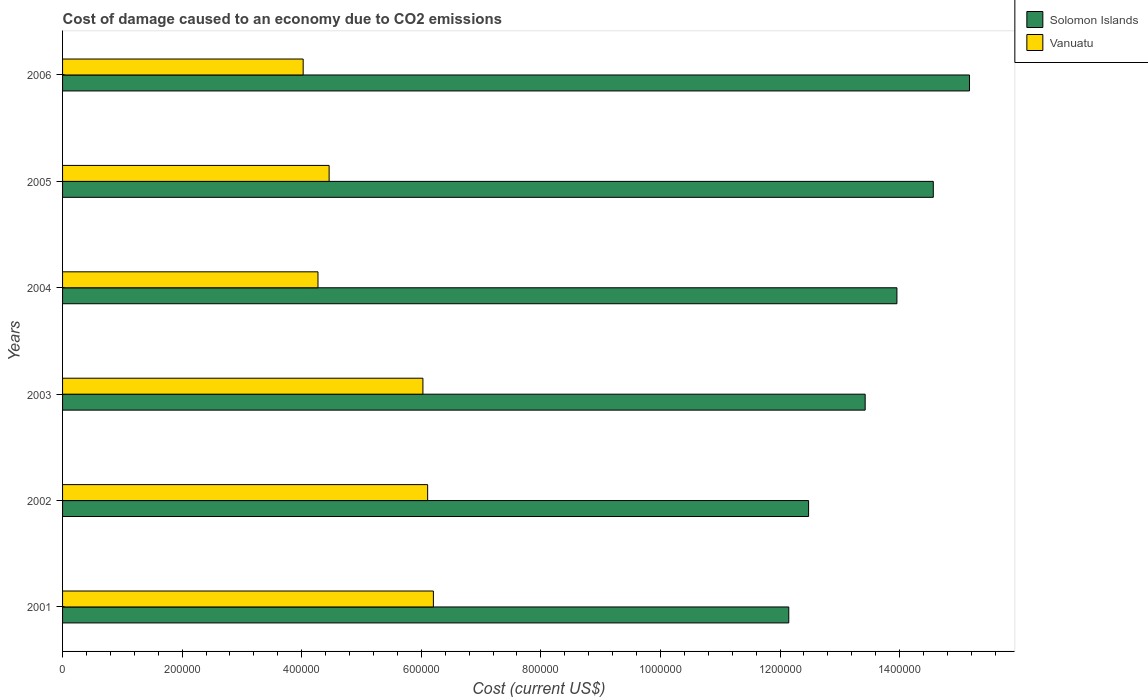How many groups of bars are there?
Provide a succinct answer. 6. Are the number of bars on each tick of the Y-axis equal?
Give a very brief answer. Yes. What is the label of the 1st group of bars from the top?
Offer a terse response. 2006. In how many cases, is the number of bars for a given year not equal to the number of legend labels?
Make the answer very short. 0. What is the cost of damage caused due to CO2 emissisons in Vanuatu in 2002?
Your answer should be compact. 6.11e+05. Across all years, what is the maximum cost of damage caused due to CO2 emissisons in Solomon Islands?
Provide a short and direct response. 1.52e+06. Across all years, what is the minimum cost of damage caused due to CO2 emissisons in Solomon Islands?
Keep it short and to the point. 1.21e+06. In which year was the cost of damage caused due to CO2 emissisons in Solomon Islands minimum?
Offer a very short reply. 2001. What is the total cost of damage caused due to CO2 emissisons in Solomon Islands in the graph?
Make the answer very short. 8.17e+06. What is the difference between the cost of damage caused due to CO2 emissisons in Vanuatu in 2001 and that in 2005?
Offer a very short reply. 1.74e+05. What is the difference between the cost of damage caused due to CO2 emissisons in Solomon Islands in 2004 and the cost of damage caused due to CO2 emissisons in Vanuatu in 2003?
Ensure brevity in your answer.  7.93e+05. What is the average cost of damage caused due to CO2 emissisons in Vanuatu per year?
Ensure brevity in your answer.  5.18e+05. In the year 2005, what is the difference between the cost of damage caused due to CO2 emissisons in Vanuatu and cost of damage caused due to CO2 emissisons in Solomon Islands?
Offer a terse response. -1.01e+06. In how many years, is the cost of damage caused due to CO2 emissisons in Solomon Islands greater than 360000 US$?
Keep it short and to the point. 6. What is the ratio of the cost of damage caused due to CO2 emissisons in Vanuatu in 2004 to that in 2006?
Keep it short and to the point. 1.06. What is the difference between the highest and the second highest cost of damage caused due to CO2 emissisons in Vanuatu?
Your answer should be compact. 9623.03. What is the difference between the highest and the lowest cost of damage caused due to CO2 emissisons in Solomon Islands?
Your response must be concise. 3.02e+05. In how many years, is the cost of damage caused due to CO2 emissisons in Vanuatu greater than the average cost of damage caused due to CO2 emissisons in Vanuatu taken over all years?
Your response must be concise. 3. What does the 2nd bar from the top in 2004 represents?
Offer a very short reply. Solomon Islands. What does the 2nd bar from the bottom in 2006 represents?
Provide a short and direct response. Vanuatu. How many bars are there?
Offer a very short reply. 12. Are all the bars in the graph horizontal?
Provide a short and direct response. Yes. How many years are there in the graph?
Provide a short and direct response. 6. What is the difference between two consecutive major ticks on the X-axis?
Your response must be concise. 2.00e+05. Does the graph contain any zero values?
Provide a succinct answer. No. Where does the legend appear in the graph?
Offer a very short reply. Top right. How many legend labels are there?
Keep it short and to the point. 2. How are the legend labels stacked?
Provide a short and direct response. Vertical. What is the title of the graph?
Offer a very short reply. Cost of damage caused to an economy due to CO2 emissions. Does "Germany" appear as one of the legend labels in the graph?
Provide a succinct answer. No. What is the label or title of the X-axis?
Provide a succinct answer. Cost (current US$). What is the label or title of the Y-axis?
Keep it short and to the point. Years. What is the Cost (current US$) of Solomon Islands in 2001?
Make the answer very short. 1.21e+06. What is the Cost (current US$) of Vanuatu in 2001?
Make the answer very short. 6.20e+05. What is the Cost (current US$) in Solomon Islands in 2002?
Keep it short and to the point. 1.25e+06. What is the Cost (current US$) in Vanuatu in 2002?
Offer a very short reply. 6.11e+05. What is the Cost (current US$) of Solomon Islands in 2003?
Provide a succinct answer. 1.34e+06. What is the Cost (current US$) in Vanuatu in 2003?
Your answer should be very brief. 6.03e+05. What is the Cost (current US$) of Solomon Islands in 2004?
Provide a short and direct response. 1.40e+06. What is the Cost (current US$) in Vanuatu in 2004?
Make the answer very short. 4.27e+05. What is the Cost (current US$) of Solomon Islands in 2005?
Give a very brief answer. 1.46e+06. What is the Cost (current US$) of Vanuatu in 2005?
Offer a terse response. 4.46e+05. What is the Cost (current US$) of Solomon Islands in 2006?
Ensure brevity in your answer.  1.52e+06. What is the Cost (current US$) in Vanuatu in 2006?
Offer a terse response. 4.02e+05. Across all years, what is the maximum Cost (current US$) of Solomon Islands?
Provide a short and direct response. 1.52e+06. Across all years, what is the maximum Cost (current US$) in Vanuatu?
Ensure brevity in your answer.  6.20e+05. Across all years, what is the minimum Cost (current US$) of Solomon Islands?
Your answer should be compact. 1.21e+06. Across all years, what is the minimum Cost (current US$) of Vanuatu?
Your answer should be very brief. 4.02e+05. What is the total Cost (current US$) of Solomon Islands in the graph?
Offer a very short reply. 8.17e+06. What is the total Cost (current US$) in Vanuatu in the graph?
Provide a short and direct response. 3.11e+06. What is the difference between the Cost (current US$) of Solomon Islands in 2001 and that in 2002?
Give a very brief answer. -3.31e+04. What is the difference between the Cost (current US$) in Vanuatu in 2001 and that in 2002?
Give a very brief answer. 9623.03. What is the difference between the Cost (current US$) in Solomon Islands in 2001 and that in 2003?
Your answer should be compact. -1.28e+05. What is the difference between the Cost (current US$) in Vanuatu in 2001 and that in 2003?
Make the answer very short. 1.75e+04. What is the difference between the Cost (current US$) of Solomon Islands in 2001 and that in 2004?
Give a very brief answer. -1.81e+05. What is the difference between the Cost (current US$) in Vanuatu in 2001 and that in 2004?
Provide a short and direct response. 1.93e+05. What is the difference between the Cost (current US$) in Solomon Islands in 2001 and that in 2005?
Keep it short and to the point. -2.42e+05. What is the difference between the Cost (current US$) in Vanuatu in 2001 and that in 2005?
Provide a short and direct response. 1.74e+05. What is the difference between the Cost (current US$) in Solomon Islands in 2001 and that in 2006?
Your response must be concise. -3.02e+05. What is the difference between the Cost (current US$) of Vanuatu in 2001 and that in 2006?
Make the answer very short. 2.18e+05. What is the difference between the Cost (current US$) of Solomon Islands in 2002 and that in 2003?
Give a very brief answer. -9.46e+04. What is the difference between the Cost (current US$) of Vanuatu in 2002 and that in 2003?
Keep it short and to the point. 7900.54. What is the difference between the Cost (current US$) in Solomon Islands in 2002 and that in 2004?
Offer a terse response. -1.48e+05. What is the difference between the Cost (current US$) in Vanuatu in 2002 and that in 2004?
Keep it short and to the point. 1.83e+05. What is the difference between the Cost (current US$) of Solomon Islands in 2002 and that in 2005?
Keep it short and to the point. -2.09e+05. What is the difference between the Cost (current US$) in Vanuatu in 2002 and that in 2005?
Make the answer very short. 1.65e+05. What is the difference between the Cost (current US$) of Solomon Islands in 2002 and that in 2006?
Keep it short and to the point. -2.69e+05. What is the difference between the Cost (current US$) in Vanuatu in 2002 and that in 2006?
Your answer should be compact. 2.08e+05. What is the difference between the Cost (current US$) of Solomon Islands in 2003 and that in 2004?
Offer a very short reply. -5.31e+04. What is the difference between the Cost (current US$) in Vanuatu in 2003 and that in 2004?
Your answer should be compact. 1.76e+05. What is the difference between the Cost (current US$) of Solomon Islands in 2003 and that in 2005?
Your answer should be very brief. -1.14e+05. What is the difference between the Cost (current US$) of Vanuatu in 2003 and that in 2005?
Ensure brevity in your answer.  1.57e+05. What is the difference between the Cost (current US$) in Solomon Islands in 2003 and that in 2006?
Offer a very short reply. -1.74e+05. What is the difference between the Cost (current US$) of Vanuatu in 2003 and that in 2006?
Offer a terse response. 2.00e+05. What is the difference between the Cost (current US$) in Solomon Islands in 2004 and that in 2005?
Give a very brief answer. -6.08e+04. What is the difference between the Cost (current US$) of Vanuatu in 2004 and that in 2005?
Provide a short and direct response. -1.86e+04. What is the difference between the Cost (current US$) of Solomon Islands in 2004 and that in 2006?
Give a very brief answer. -1.21e+05. What is the difference between the Cost (current US$) in Vanuatu in 2004 and that in 2006?
Keep it short and to the point. 2.48e+04. What is the difference between the Cost (current US$) of Solomon Islands in 2005 and that in 2006?
Make the answer very short. -6.05e+04. What is the difference between the Cost (current US$) of Vanuatu in 2005 and that in 2006?
Offer a terse response. 4.34e+04. What is the difference between the Cost (current US$) of Solomon Islands in 2001 and the Cost (current US$) of Vanuatu in 2002?
Make the answer very short. 6.04e+05. What is the difference between the Cost (current US$) of Solomon Islands in 2001 and the Cost (current US$) of Vanuatu in 2003?
Provide a succinct answer. 6.12e+05. What is the difference between the Cost (current US$) of Solomon Islands in 2001 and the Cost (current US$) of Vanuatu in 2004?
Provide a short and direct response. 7.87e+05. What is the difference between the Cost (current US$) of Solomon Islands in 2001 and the Cost (current US$) of Vanuatu in 2005?
Your answer should be compact. 7.69e+05. What is the difference between the Cost (current US$) in Solomon Islands in 2001 and the Cost (current US$) in Vanuatu in 2006?
Your answer should be very brief. 8.12e+05. What is the difference between the Cost (current US$) in Solomon Islands in 2002 and the Cost (current US$) in Vanuatu in 2003?
Give a very brief answer. 6.45e+05. What is the difference between the Cost (current US$) of Solomon Islands in 2002 and the Cost (current US$) of Vanuatu in 2004?
Give a very brief answer. 8.21e+05. What is the difference between the Cost (current US$) of Solomon Islands in 2002 and the Cost (current US$) of Vanuatu in 2005?
Make the answer very short. 8.02e+05. What is the difference between the Cost (current US$) in Solomon Islands in 2002 and the Cost (current US$) in Vanuatu in 2006?
Offer a terse response. 8.45e+05. What is the difference between the Cost (current US$) in Solomon Islands in 2003 and the Cost (current US$) in Vanuatu in 2004?
Offer a terse response. 9.15e+05. What is the difference between the Cost (current US$) of Solomon Islands in 2003 and the Cost (current US$) of Vanuatu in 2005?
Provide a succinct answer. 8.97e+05. What is the difference between the Cost (current US$) in Solomon Islands in 2003 and the Cost (current US$) in Vanuatu in 2006?
Your answer should be compact. 9.40e+05. What is the difference between the Cost (current US$) in Solomon Islands in 2004 and the Cost (current US$) in Vanuatu in 2005?
Provide a succinct answer. 9.50e+05. What is the difference between the Cost (current US$) of Solomon Islands in 2004 and the Cost (current US$) of Vanuatu in 2006?
Offer a terse response. 9.93e+05. What is the difference between the Cost (current US$) of Solomon Islands in 2005 and the Cost (current US$) of Vanuatu in 2006?
Offer a terse response. 1.05e+06. What is the average Cost (current US$) of Solomon Islands per year?
Provide a succinct answer. 1.36e+06. What is the average Cost (current US$) in Vanuatu per year?
Your answer should be compact. 5.18e+05. In the year 2001, what is the difference between the Cost (current US$) in Solomon Islands and Cost (current US$) in Vanuatu?
Ensure brevity in your answer.  5.94e+05. In the year 2002, what is the difference between the Cost (current US$) of Solomon Islands and Cost (current US$) of Vanuatu?
Your answer should be compact. 6.37e+05. In the year 2003, what is the difference between the Cost (current US$) in Solomon Islands and Cost (current US$) in Vanuatu?
Make the answer very short. 7.40e+05. In the year 2004, what is the difference between the Cost (current US$) of Solomon Islands and Cost (current US$) of Vanuatu?
Provide a short and direct response. 9.68e+05. In the year 2005, what is the difference between the Cost (current US$) of Solomon Islands and Cost (current US$) of Vanuatu?
Your answer should be very brief. 1.01e+06. In the year 2006, what is the difference between the Cost (current US$) of Solomon Islands and Cost (current US$) of Vanuatu?
Ensure brevity in your answer.  1.11e+06. What is the ratio of the Cost (current US$) in Solomon Islands in 2001 to that in 2002?
Provide a succinct answer. 0.97. What is the ratio of the Cost (current US$) of Vanuatu in 2001 to that in 2002?
Your response must be concise. 1.02. What is the ratio of the Cost (current US$) in Solomon Islands in 2001 to that in 2003?
Provide a succinct answer. 0.9. What is the ratio of the Cost (current US$) of Vanuatu in 2001 to that in 2003?
Keep it short and to the point. 1.03. What is the ratio of the Cost (current US$) in Solomon Islands in 2001 to that in 2004?
Provide a succinct answer. 0.87. What is the ratio of the Cost (current US$) of Vanuatu in 2001 to that in 2004?
Ensure brevity in your answer.  1.45. What is the ratio of the Cost (current US$) in Solomon Islands in 2001 to that in 2005?
Make the answer very short. 0.83. What is the ratio of the Cost (current US$) in Vanuatu in 2001 to that in 2005?
Provide a short and direct response. 1.39. What is the ratio of the Cost (current US$) in Solomon Islands in 2001 to that in 2006?
Give a very brief answer. 0.8. What is the ratio of the Cost (current US$) of Vanuatu in 2001 to that in 2006?
Your response must be concise. 1.54. What is the ratio of the Cost (current US$) in Solomon Islands in 2002 to that in 2003?
Make the answer very short. 0.93. What is the ratio of the Cost (current US$) of Vanuatu in 2002 to that in 2003?
Offer a terse response. 1.01. What is the ratio of the Cost (current US$) in Solomon Islands in 2002 to that in 2004?
Your answer should be very brief. 0.89. What is the ratio of the Cost (current US$) in Vanuatu in 2002 to that in 2004?
Your answer should be compact. 1.43. What is the ratio of the Cost (current US$) of Solomon Islands in 2002 to that in 2005?
Your answer should be very brief. 0.86. What is the ratio of the Cost (current US$) of Vanuatu in 2002 to that in 2005?
Ensure brevity in your answer.  1.37. What is the ratio of the Cost (current US$) in Solomon Islands in 2002 to that in 2006?
Offer a very short reply. 0.82. What is the ratio of the Cost (current US$) of Vanuatu in 2002 to that in 2006?
Your answer should be compact. 1.52. What is the ratio of the Cost (current US$) of Solomon Islands in 2003 to that in 2004?
Provide a succinct answer. 0.96. What is the ratio of the Cost (current US$) of Vanuatu in 2003 to that in 2004?
Offer a very short reply. 1.41. What is the ratio of the Cost (current US$) of Solomon Islands in 2003 to that in 2005?
Provide a short and direct response. 0.92. What is the ratio of the Cost (current US$) of Vanuatu in 2003 to that in 2005?
Give a very brief answer. 1.35. What is the ratio of the Cost (current US$) of Solomon Islands in 2003 to that in 2006?
Offer a terse response. 0.89. What is the ratio of the Cost (current US$) in Vanuatu in 2003 to that in 2006?
Your answer should be very brief. 1.5. What is the ratio of the Cost (current US$) in Solomon Islands in 2004 to that in 2005?
Ensure brevity in your answer.  0.96. What is the ratio of the Cost (current US$) in Vanuatu in 2004 to that in 2005?
Ensure brevity in your answer.  0.96. What is the ratio of the Cost (current US$) in Vanuatu in 2004 to that in 2006?
Provide a short and direct response. 1.06. What is the ratio of the Cost (current US$) in Solomon Islands in 2005 to that in 2006?
Keep it short and to the point. 0.96. What is the ratio of the Cost (current US$) of Vanuatu in 2005 to that in 2006?
Offer a very short reply. 1.11. What is the difference between the highest and the second highest Cost (current US$) in Solomon Islands?
Provide a succinct answer. 6.05e+04. What is the difference between the highest and the second highest Cost (current US$) in Vanuatu?
Your answer should be compact. 9623.03. What is the difference between the highest and the lowest Cost (current US$) of Solomon Islands?
Provide a succinct answer. 3.02e+05. What is the difference between the highest and the lowest Cost (current US$) of Vanuatu?
Your answer should be very brief. 2.18e+05. 